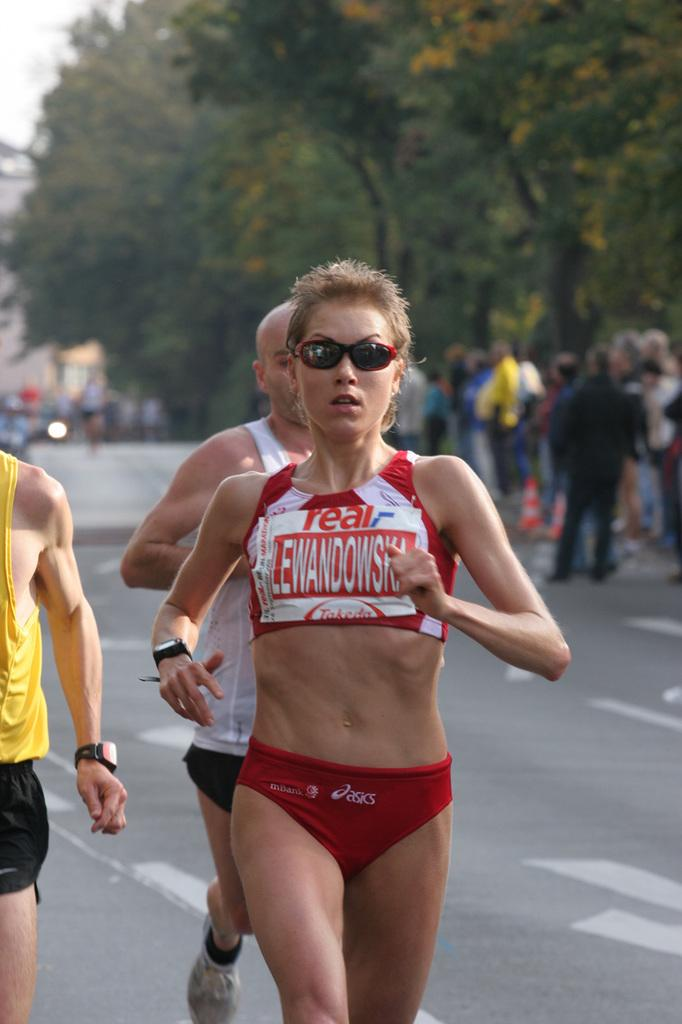<image>
Write a terse but informative summary of the picture. A woman running with Lewandowski on her shirt. 